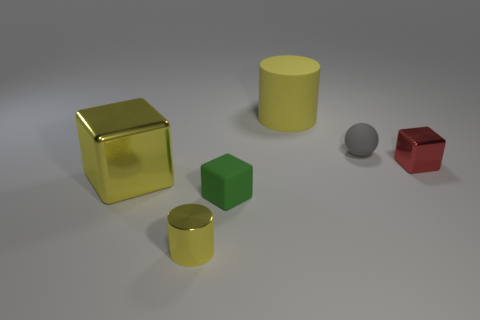Is the large rubber cylinder the same color as the large metal block?
Give a very brief answer. Yes. How many shiny things are the same color as the big matte cylinder?
Provide a short and direct response. 2. There is another cube that is the same material as the large yellow block; what color is it?
Your answer should be compact. Red. Is there a small metal object to the right of the rubber cylinder that is behind the green block?
Ensure brevity in your answer.  Yes. How many other objects are the same shape as the gray thing?
Make the answer very short. 0. There is a object that is right of the small gray sphere; is its shape the same as the small matte thing in front of the tiny rubber ball?
Provide a succinct answer. Yes. What number of tiny gray matte things are in front of the shiny thing to the right of the small rubber object that is on the right side of the green rubber cube?
Provide a succinct answer. 0. What color is the metallic cylinder?
Your answer should be compact. Yellow. How many other things are the same size as the gray thing?
Provide a short and direct response. 3. What material is the other green object that is the same shape as the big metallic thing?
Provide a short and direct response. Rubber. 